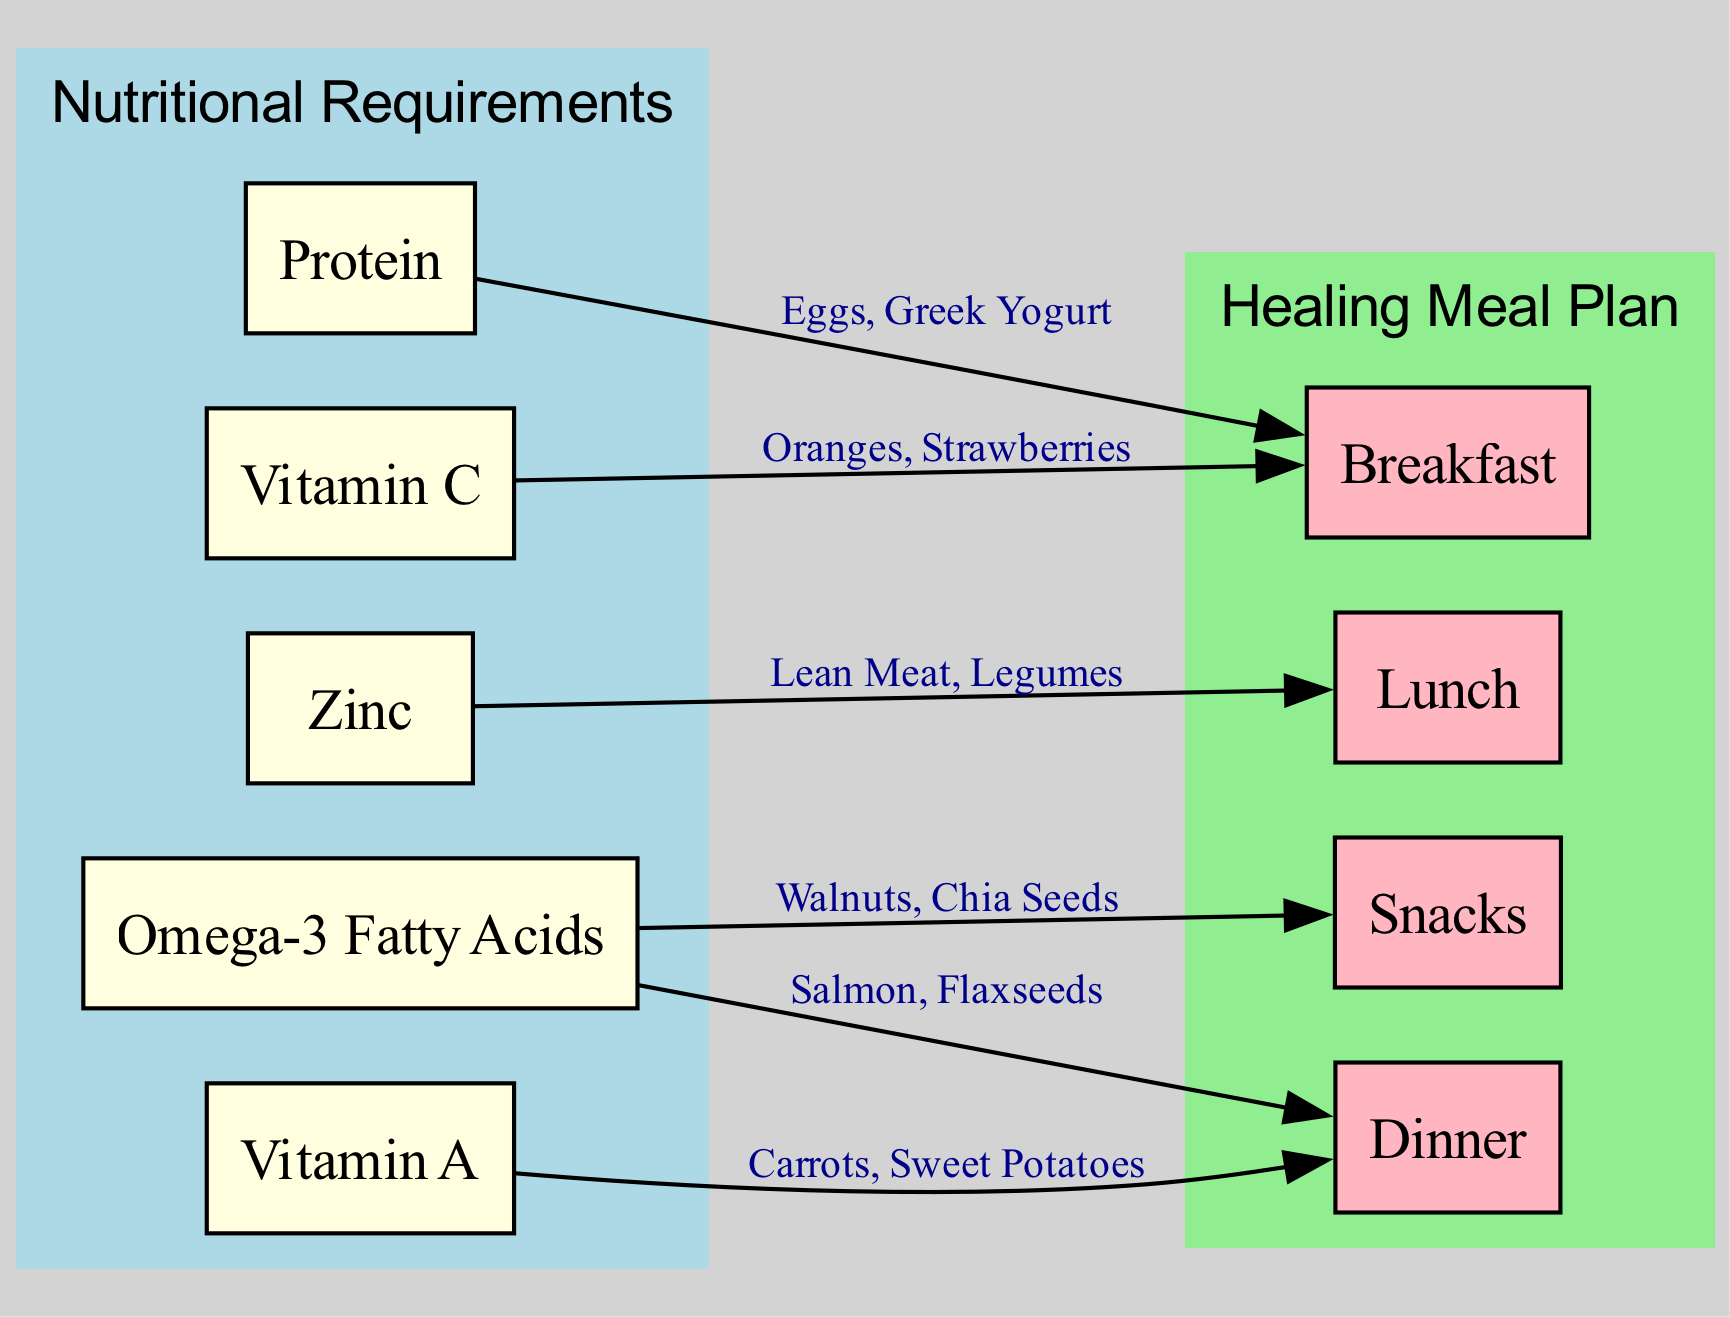What are the elements under Nutritional Requirements? The diagram lists five elements under the category of 'Nutritional Requirements': Protein, Vitamin C, Zinc, Omega-3 Fatty Acids, and Vitamin A.
Answer: Protein, Vitamin C, Zinc, Omega-3 Fatty Acids, Vitamin A Which meal plan element is associated with Zinc? The diagram indicates that Zinc is connected to the Lunch meal plan element, suggesting specific food items for that meal.
Answer: Lunch How many edges are in the diagram? By counting all the connections made in the edges section of the diagram, we find there are six edges linking the nutritional requirements to their respective meal elements.
Answer: 6 What food items are linked to Omega-3 Fatty Acids? Omega-3 Fatty Acids connect to two meal plan elements: Dinner (Salmon, Flaxseeds) and Snacks (Walnuts, Chia Seeds), providing options for these meals.
Answer: Salmon, Flaxseeds; Walnuts, Chia Seeds What category does Breakfast belong to? Breakfast is grouped under the category of 'Healing Meal Plan', which organizes different meal suggestions aimed at promoting skin healing.
Answer: Healing Meal Plan Which two nutrients are associated with Dinner? The diagram shows that Dinner is connected to two nutrients: Omega-3 Fatty Acids and Vitamin A, denoting the food items correlated with this meal plan.
Answer: Omega-3 Fatty Acids, Vitamin A Which food items are recommended for Breakfast that include Vitamin C? The diagram specifies that Vitamin C is linked to Breakfast, with food items including Oranges and Strawberries as appropriate sources.
Answer: Oranges, Strawberries Is there a direct connection between snacks and any nutritional requirements? Yes, Snacks are directly linked to Omega-3 Fatty Acids, showing specific food items that can serve as snacks enriching in this nutrient.
Answer: Omega-3 Fatty Acids In total, how many elements are listed in the Healing Meal Plan? The Healing Meal Plan consists of four elements: Breakfast, Lunch, Dinner, and Snacks, outlining comprehensive meal options.
Answer: 4 